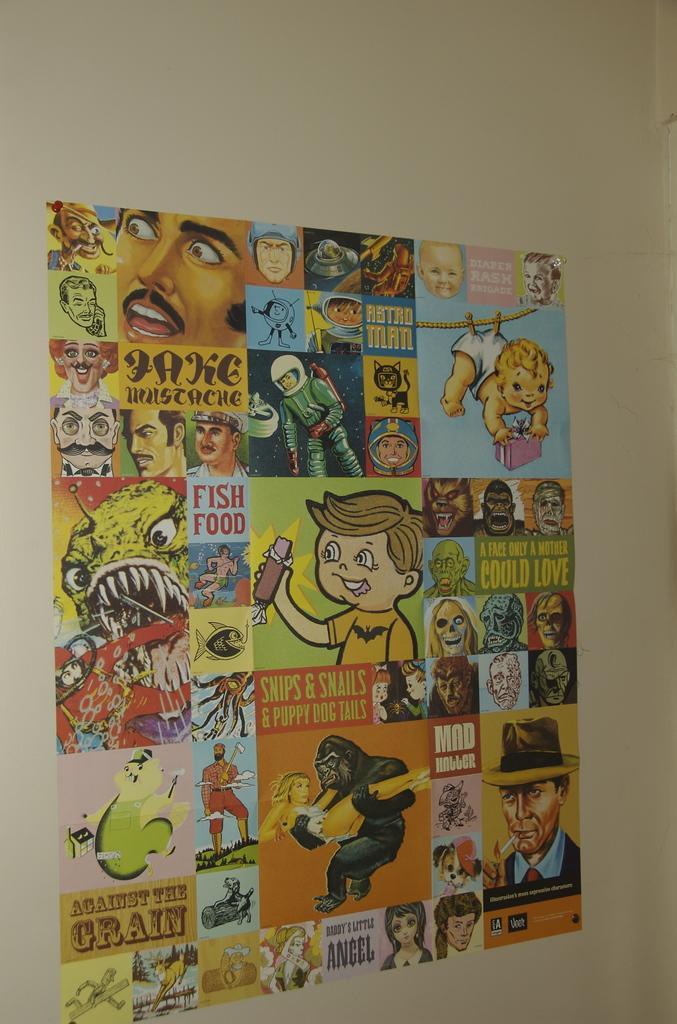Can you describe this image briefly? A poster is on wall. Animated pictures are on poster. 